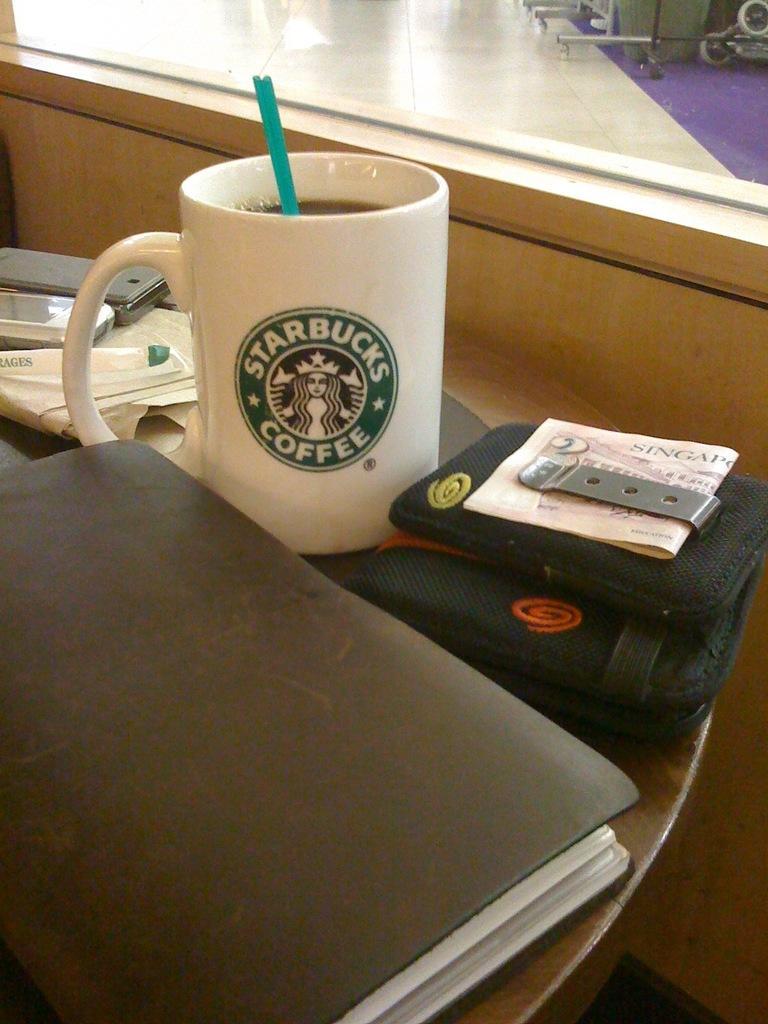How would you summarize this image in a sentence or two? In this image I can see a cup where Starbucks Coffee is written on it. I can also see few more stuffs on this table. 